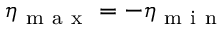Convert formula to latex. <formula><loc_0><loc_0><loc_500><loc_500>\eta _ { m a x } = - \eta _ { m i n }</formula> 